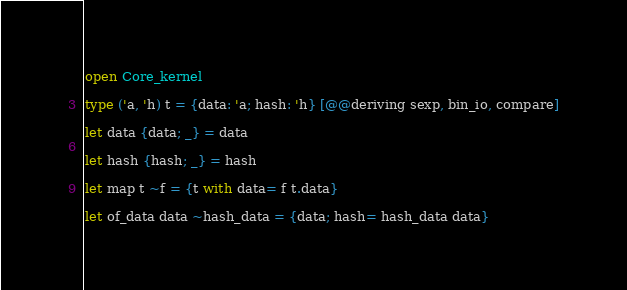<code> <loc_0><loc_0><loc_500><loc_500><_OCaml_>open Core_kernel

type ('a, 'h) t = {data: 'a; hash: 'h} [@@deriving sexp, bin_io, compare]

let data {data; _} = data

let hash {hash; _} = hash

let map t ~f = {t with data= f t.data}

let of_data data ~hash_data = {data; hash= hash_data data}
</code> 